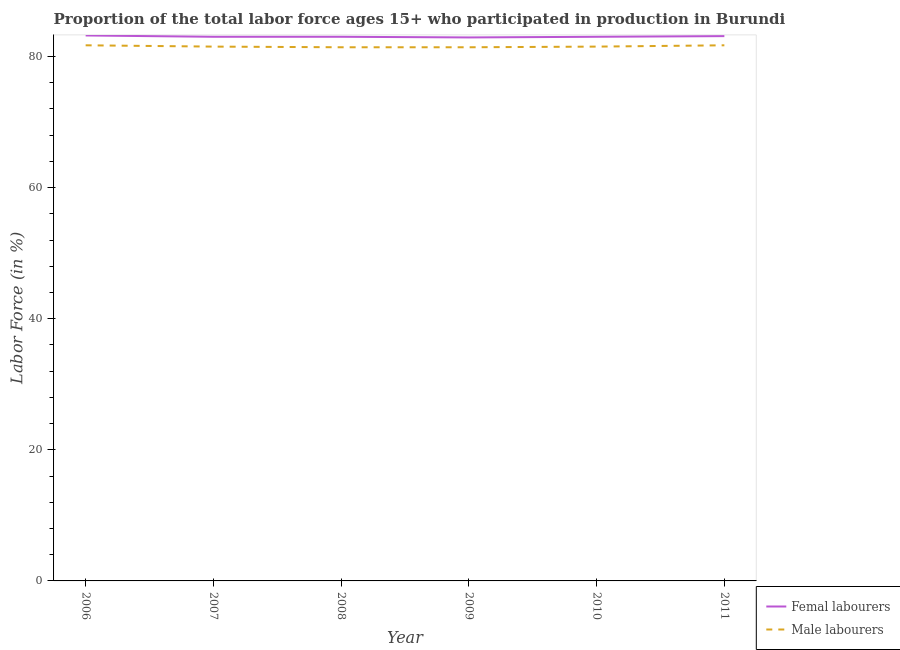Does the line corresponding to percentage of female labor force intersect with the line corresponding to percentage of male labour force?
Offer a terse response. No. Is the number of lines equal to the number of legend labels?
Give a very brief answer. Yes. What is the percentage of male labour force in 2007?
Offer a very short reply. 81.5. Across all years, what is the maximum percentage of male labour force?
Your response must be concise. 81.7. Across all years, what is the minimum percentage of male labour force?
Make the answer very short. 81.4. In which year was the percentage of female labor force maximum?
Ensure brevity in your answer.  2006. In which year was the percentage of female labor force minimum?
Your answer should be very brief. 2009. What is the total percentage of female labor force in the graph?
Give a very brief answer. 498.2. What is the difference between the percentage of male labour force in 2006 and the percentage of female labor force in 2011?
Provide a succinct answer. -1.4. What is the average percentage of female labor force per year?
Ensure brevity in your answer.  83.03. In the year 2010, what is the difference between the percentage of female labor force and percentage of male labour force?
Offer a very short reply. 1.5. In how many years, is the percentage of female labor force greater than 52 %?
Your response must be concise. 6. What is the ratio of the percentage of male labour force in 2006 to that in 2007?
Keep it short and to the point. 1. Is the percentage of female labor force in 2006 less than that in 2008?
Make the answer very short. No. Is the difference between the percentage of male labour force in 2009 and 2011 greater than the difference between the percentage of female labor force in 2009 and 2011?
Offer a very short reply. No. What is the difference between the highest and the lowest percentage of female labor force?
Make the answer very short. 0.3. Is the sum of the percentage of female labor force in 2009 and 2011 greater than the maximum percentage of male labour force across all years?
Your answer should be very brief. Yes. Is the percentage of female labor force strictly less than the percentage of male labour force over the years?
Your response must be concise. No. Does the graph contain any zero values?
Offer a very short reply. No. Does the graph contain grids?
Keep it short and to the point. No. How many legend labels are there?
Offer a very short reply. 2. What is the title of the graph?
Give a very brief answer. Proportion of the total labor force ages 15+ who participated in production in Burundi. What is the label or title of the Y-axis?
Provide a succinct answer. Labor Force (in %). What is the Labor Force (in %) of Femal labourers in 2006?
Ensure brevity in your answer.  83.2. What is the Labor Force (in %) in Male labourers in 2006?
Your answer should be compact. 81.7. What is the Labor Force (in %) of Femal labourers in 2007?
Provide a short and direct response. 83. What is the Labor Force (in %) of Male labourers in 2007?
Keep it short and to the point. 81.5. What is the Labor Force (in %) in Male labourers in 2008?
Offer a very short reply. 81.4. What is the Labor Force (in %) in Femal labourers in 2009?
Provide a succinct answer. 82.9. What is the Labor Force (in %) of Male labourers in 2009?
Your answer should be compact. 81.4. What is the Labor Force (in %) of Male labourers in 2010?
Provide a succinct answer. 81.5. What is the Labor Force (in %) of Femal labourers in 2011?
Your answer should be very brief. 83.1. What is the Labor Force (in %) in Male labourers in 2011?
Your answer should be compact. 81.7. Across all years, what is the maximum Labor Force (in %) in Femal labourers?
Offer a very short reply. 83.2. Across all years, what is the maximum Labor Force (in %) of Male labourers?
Keep it short and to the point. 81.7. Across all years, what is the minimum Labor Force (in %) in Femal labourers?
Offer a terse response. 82.9. Across all years, what is the minimum Labor Force (in %) of Male labourers?
Keep it short and to the point. 81.4. What is the total Labor Force (in %) of Femal labourers in the graph?
Provide a succinct answer. 498.2. What is the total Labor Force (in %) of Male labourers in the graph?
Offer a very short reply. 489.2. What is the difference between the Labor Force (in %) of Femal labourers in 2006 and that in 2008?
Your answer should be very brief. 0.2. What is the difference between the Labor Force (in %) of Male labourers in 2006 and that in 2008?
Make the answer very short. 0.3. What is the difference between the Labor Force (in %) of Femal labourers in 2006 and that in 2009?
Your answer should be very brief. 0.3. What is the difference between the Labor Force (in %) of Femal labourers in 2006 and that in 2010?
Offer a very short reply. 0.2. What is the difference between the Labor Force (in %) in Male labourers in 2006 and that in 2011?
Keep it short and to the point. 0. What is the difference between the Labor Force (in %) of Femal labourers in 2007 and that in 2008?
Provide a short and direct response. 0. What is the difference between the Labor Force (in %) in Male labourers in 2007 and that in 2008?
Provide a short and direct response. 0.1. What is the difference between the Labor Force (in %) in Male labourers in 2007 and that in 2009?
Provide a succinct answer. 0.1. What is the difference between the Labor Force (in %) in Male labourers in 2007 and that in 2011?
Your response must be concise. -0.2. What is the difference between the Labor Force (in %) of Femal labourers in 2008 and that in 2009?
Ensure brevity in your answer.  0.1. What is the difference between the Labor Force (in %) in Male labourers in 2008 and that in 2009?
Provide a short and direct response. 0. What is the difference between the Labor Force (in %) in Femal labourers in 2008 and that in 2010?
Your answer should be compact. 0. What is the difference between the Labor Force (in %) of Male labourers in 2008 and that in 2010?
Offer a terse response. -0.1. What is the difference between the Labor Force (in %) in Femal labourers in 2009 and that in 2011?
Your response must be concise. -0.2. What is the difference between the Labor Force (in %) in Femal labourers in 2010 and that in 2011?
Your response must be concise. -0.1. What is the difference between the Labor Force (in %) of Male labourers in 2010 and that in 2011?
Make the answer very short. -0.2. What is the difference between the Labor Force (in %) of Femal labourers in 2006 and the Labor Force (in %) of Male labourers in 2008?
Provide a short and direct response. 1.8. What is the difference between the Labor Force (in %) in Femal labourers in 2006 and the Labor Force (in %) in Male labourers in 2011?
Your answer should be very brief. 1.5. What is the difference between the Labor Force (in %) in Femal labourers in 2007 and the Labor Force (in %) in Male labourers in 2010?
Your response must be concise. 1.5. What is the difference between the Labor Force (in %) in Femal labourers in 2008 and the Labor Force (in %) in Male labourers in 2011?
Offer a terse response. 1.3. What is the difference between the Labor Force (in %) of Femal labourers in 2009 and the Labor Force (in %) of Male labourers in 2010?
Your answer should be very brief. 1.4. What is the difference between the Labor Force (in %) in Femal labourers in 2010 and the Labor Force (in %) in Male labourers in 2011?
Provide a succinct answer. 1.3. What is the average Labor Force (in %) in Femal labourers per year?
Provide a succinct answer. 83.03. What is the average Labor Force (in %) in Male labourers per year?
Offer a very short reply. 81.53. In the year 2006, what is the difference between the Labor Force (in %) in Femal labourers and Labor Force (in %) in Male labourers?
Give a very brief answer. 1.5. In the year 2008, what is the difference between the Labor Force (in %) of Femal labourers and Labor Force (in %) of Male labourers?
Provide a succinct answer. 1.6. In the year 2011, what is the difference between the Labor Force (in %) in Femal labourers and Labor Force (in %) in Male labourers?
Ensure brevity in your answer.  1.4. What is the ratio of the Labor Force (in %) in Femal labourers in 2006 to that in 2009?
Your answer should be compact. 1. What is the ratio of the Labor Force (in %) in Femal labourers in 2006 to that in 2010?
Ensure brevity in your answer.  1. What is the ratio of the Labor Force (in %) of Femal labourers in 2006 to that in 2011?
Provide a short and direct response. 1. What is the ratio of the Labor Force (in %) in Male labourers in 2006 to that in 2011?
Keep it short and to the point. 1. What is the ratio of the Labor Force (in %) in Male labourers in 2007 to that in 2010?
Offer a very short reply. 1. What is the ratio of the Labor Force (in %) in Femal labourers in 2007 to that in 2011?
Provide a succinct answer. 1. What is the ratio of the Labor Force (in %) of Male labourers in 2008 to that in 2009?
Provide a succinct answer. 1. What is the ratio of the Labor Force (in %) in Femal labourers in 2008 to that in 2010?
Keep it short and to the point. 1. What is the ratio of the Labor Force (in %) in Male labourers in 2008 to that in 2010?
Provide a succinct answer. 1. What is the ratio of the Labor Force (in %) of Femal labourers in 2008 to that in 2011?
Your answer should be compact. 1. What is the ratio of the Labor Force (in %) of Male labourers in 2008 to that in 2011?
Your response must be concise. 1. What is the ratio of the Labor Force (in %) of Femal labourers in 2009 to that in 2010?
Provide a succinct answer. 1. What is the ratio of the Labor Force (in %) in Male labourers in 2009 to that in 2010?
Ensure brevity in your answer.  1. What is the ratio of the Labor Force (in %) of Male labourers in 2010 to that in 2011?
Keep it short and to the point. 1. What is the difference between the highest and the second highest Labor Force (in %) in Male labourers?
Offer a very short reply. 0. What is the difference between the highest and the lowest Labor Force (in %) in Male labourers?
Ensure brevity in your answer.  0.3. 